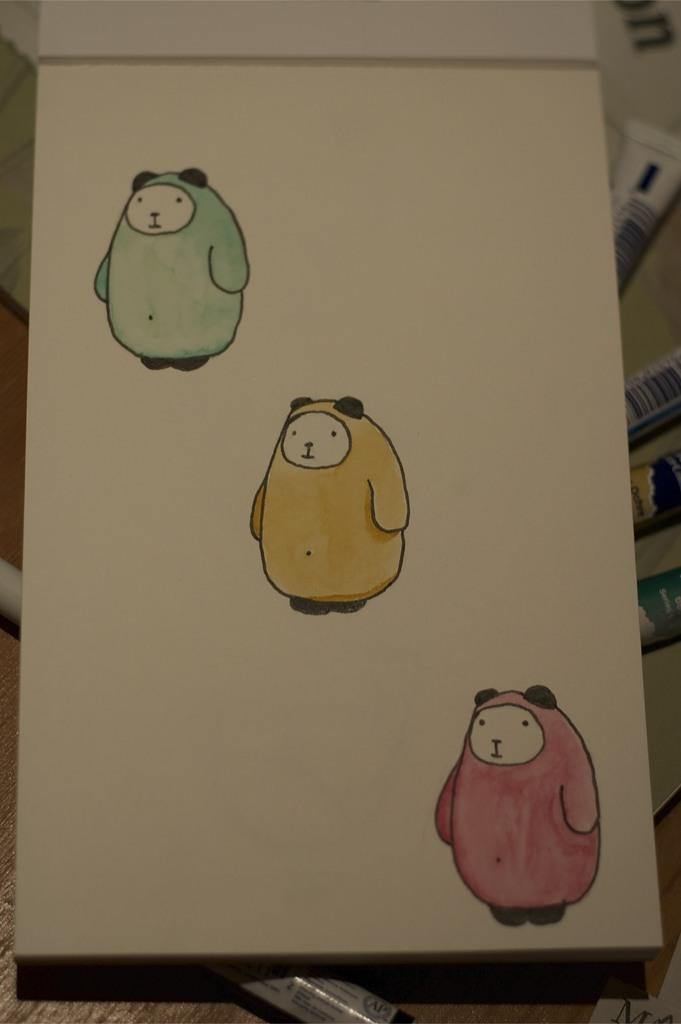What is present on the paper in the image? The paper has paintings on it. What might be used to create the paintings on the paper? There are paint tubes below the paper, which could be used to create the paintings. What is the surface that the paper and paint tubes are placed on? There is a surface in the image, but its specific characteristics are not mentioned. What type of science experiment is being conducted with the flame in the image? There is no flame present in the image, so it is not possible to determine if a science experiment is being conducted. 